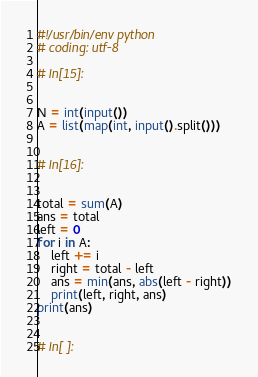Convert code to text. <code><loc_0><loc_0><loc_500><loc_500><_Python_>#!/usr/bin/env python
# coding: utf-8

# In[15]:


N = int(input())
A = list(map(int, input().split()))


# In[16]:


total = sum(A)
ans = total
left = 0
for i in A:
    left += i
    right = total - left
    ans = min(ans, abs(left - right))
    print(left, right, ans)
print(ans)


# In[ ]:




</code> 